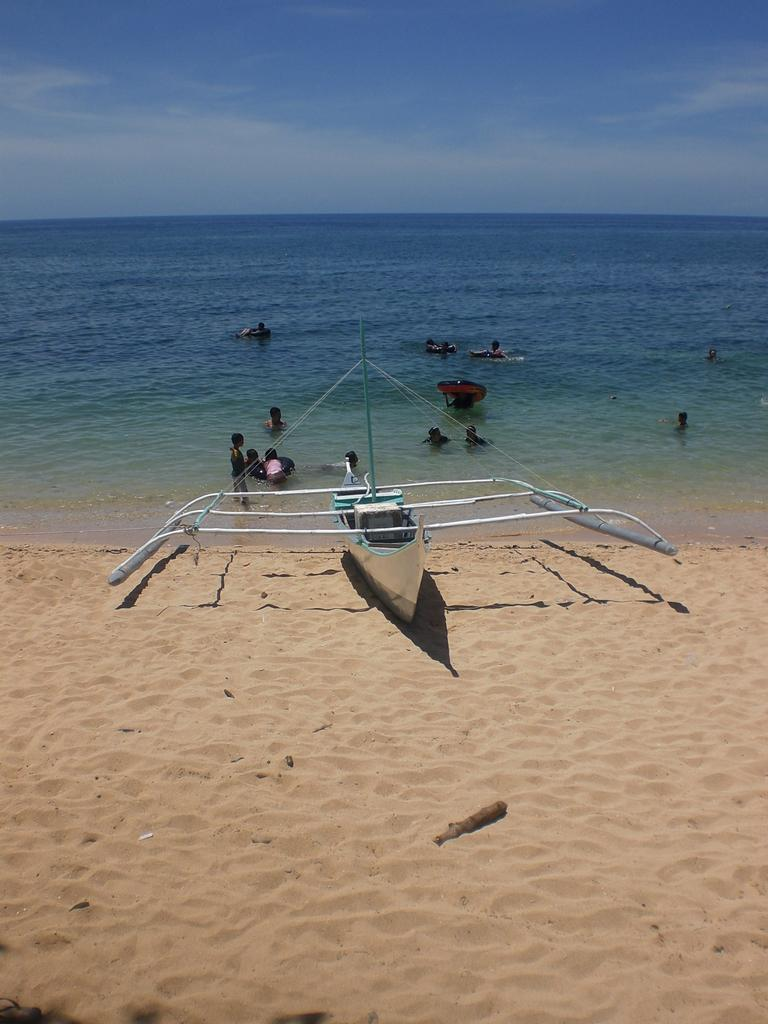What type of natural feature is present in the image? There is a sea in the image. What is happening on the sea in the image? There are persons visible on the sea. What is located in front of the sea in the image? There is a boat visible in front of the sea. What is visible at the top of the image? The sky is visible at the top of the image. What type of box is being used for the voyage in the image? There is no box or voyage present in the image; it features a sea with persons and a boat. 